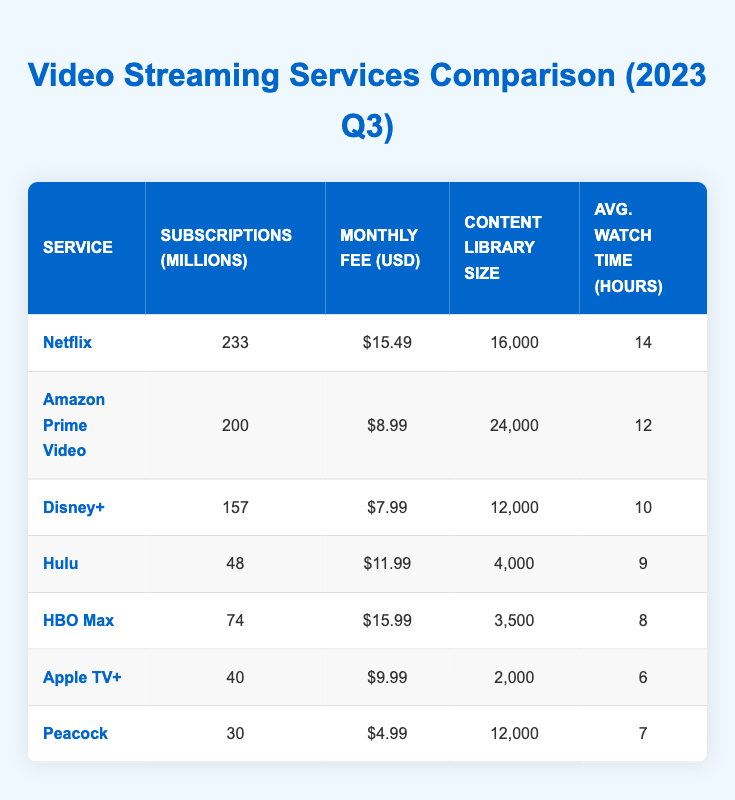What is the monthly fee for HBO Max? Referring to the table, HBO Max's monthly fee is listed as $15.99.
Answer: $15.99 How many subscriptions does Disney+ have? The table indicates that Disney+ has 157 million subscriptions.
Answer: 157 What is the total number of subscriptions for Netflix and Amazon Prime Video combined? Netflix has 233 million subscriptions, and Amazon Prime Video has 200 million. Adding these gives a total of 233 + 200 = 433 million subscriptions.
Answer: 433 Which service has the largest content library? The content library sizes for each service are as follows: Netflix (16,000), Amazon Prime Video (24,000), Disney+ (12,000), Hulu (4,000), HBO Max (3,500), Apple TV+ (2,000), and Peacock (12,000). Amazon Prime Video has the largest library with 24,000 items.
Answer: Amazon Prime Video Is the average watch time for Hulu greater than that of Apple TV+? The average watch time for Hulu is 9 hours, while for Apple TV+ it is 6 hours. Since 9 > 6, the statement is true.
Answer: Yes What is the average monthly fee of all listed services? The monthly fees are $15.49 (Netflix), $8.99 (Amazon Prime Video), $7.99 (Disney+), $11.99 (Hulu), $15.99 (HBO Max), $9.99 (Apple TV+), and $4.99 (Peacock). Adding these fees gives a total of $15.49 + $8.99 + $7.99 + $11.99 + $15.99 + $9.99 + $4.99 = $74.43, and dividing by 7 results in an average fee of $74.43 / 7 = $10.64.
Answer: $10.64 Which service has the lowest number of subscriptions? The table shows the subscriptions for each service: Netflix (233), Amazon Prime Video (200), Disney+ (157), Hulu (48), HBO Max (74), Apple TV+ (40), and Peacock (30). Peacock has the lowest subscriptions at 30 million.
Answer: Peacock What is the difference in average watch time between Netflix and Hulu? The average watch time for Netflix is 14 hours, while for Hulu it is 9 hours. The difference is 14 - 9 = 5 hours.
Answer: 5 hours Is the content library size of Hulu larger than that of HBO Max? Hulu has a content library of 4,000, while HBO Max has 3,500. Since 4,000 > 3,500, the statement is true.
Answer: Yes If you sum the total subscriptions for all services, how many subscriptions are there in total? Adding the subscriptions: 233 (Netflix) + 200 (Amazon Prime Video) + 157 (Disney+) + 48 (Hulu) + 74 (HBO Max) + 40 (Apple TV+) + 30 (Peacock) = 782 million.
Answer: 782 Which video streaming service has the highest average watch time? The average watch times are 14 hours for Netflix, 12 for Amazon Prime Video, 10 for Disney+, 9 for Hulu, 8 for HBO Max, 6 for Apple TV+, and 7 for Peacock. Comparing these, Netflix has the highest average watch time at 14 hours.
Answer: Netflix 